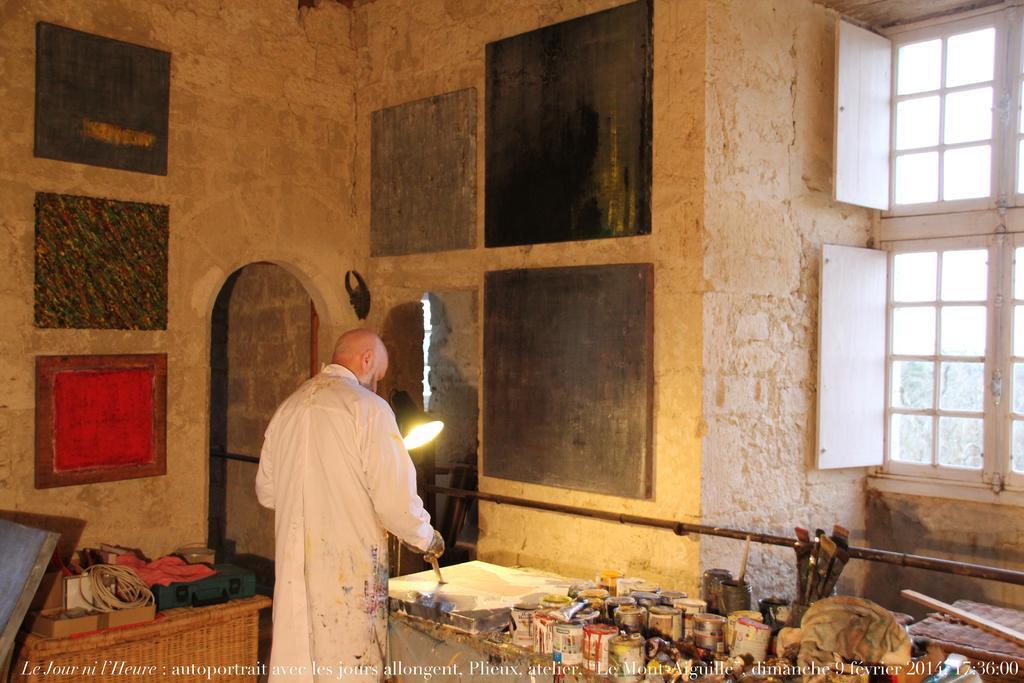How would you summarize this image in a sentence or two? This is an inside view. Here I can see a man wearing white color dress, standing in front of the table. It seems like he is painting on a board which is placed on the table. On the table, I can see some bottles, brushes, cloth and some more objects. On the left side there is another table on which a box, few clothes are placed. In the background there is a wall and few boards are attached to it and also I can see a window on the right side. 